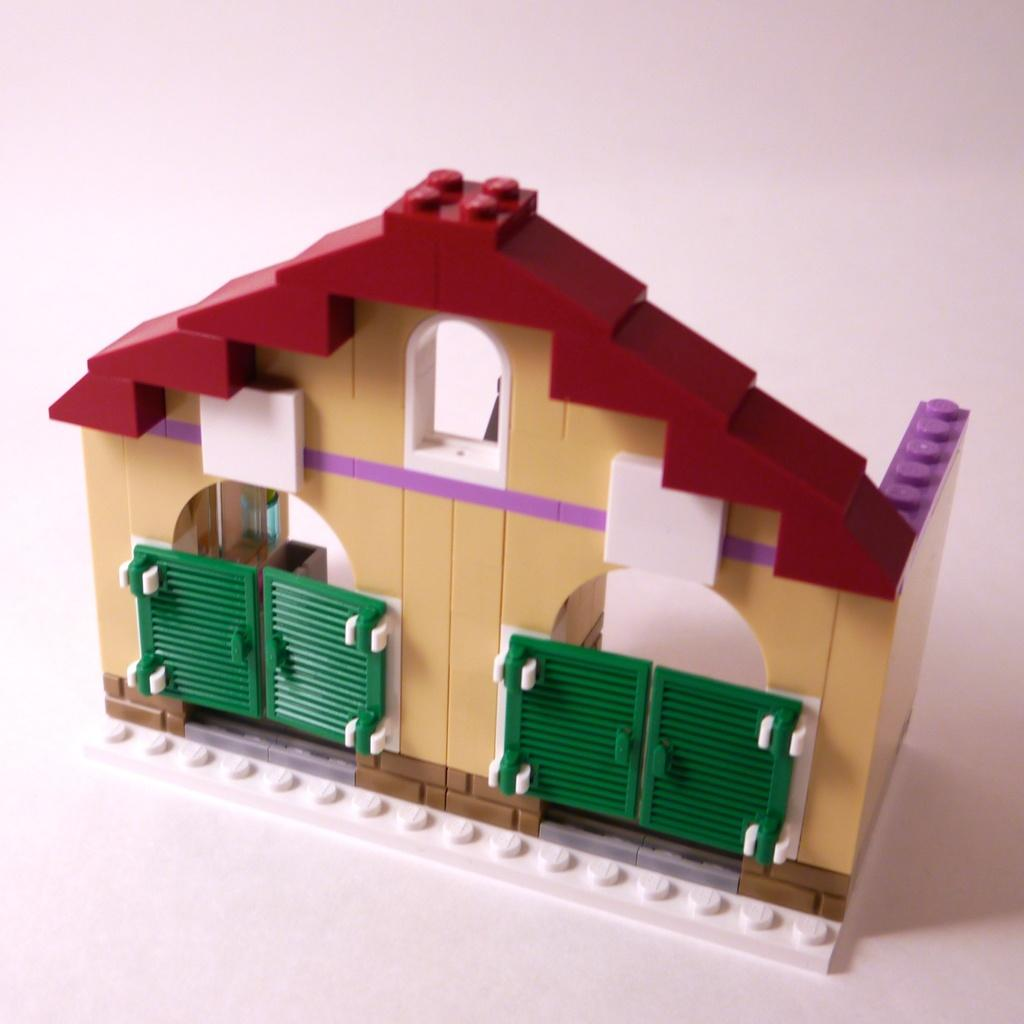What type of toy is present in the image? There is a toy house in the image. What material is the toy house made of? The toy house is made of building blocks. What feature can be seen on the toy house? The toy house has gates. What type of cake is being served at the cattle farm in the image? There is no cake or cattle farm present in the image; it features a toy house made of building blocks. 